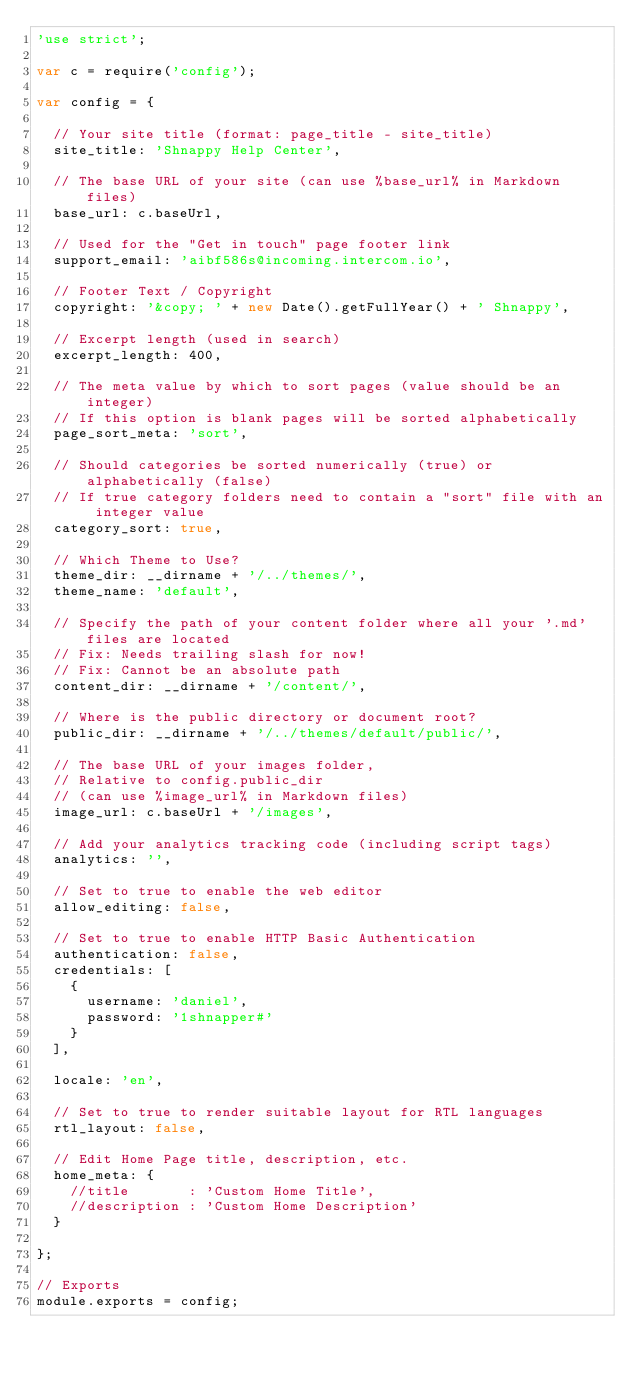Convert code to text. <code><loc_0><loc_0><loc_500><loc_500><_JavaScript_>'use strict';

var c = require('config');

var config = {

  // Your site title (format: page_title - site_title)
  site_title: 'Shnappy Help Center',

  // The base URL of your site (can use %base_url% in Markdown files)
  base_url: c.baseUrl,

  // Used for the "Get in touch" page footer link
  support_email: 'aibf586s@incoming.intercom.io',

  // Footer Text / Copyright
  copyright: '&copy; ' + new Date().getFullYear() + ' Shnappy',

  // Excerpt length (used in search)
  excerpt_length: 400,

  // The meta value by which to sort pages (value should be an integer)
  // If this option is blank pages will be sorted alphabetically
  page_sort_meta: 'sort',

  // Should categories be sorted numerically (true) or alphabetically (false)
  // If true category folders need to contain a "sort" file with an integer value
  category_sort: true,

  // Which Theme to Use?
  theme_dir: __dirname + '/../themes/',
  theme_name: 'default',

  // Specify the path of your content folder where all your '.md' files are located
  // Fix: Needs trailing slash for now!
  // Fix: Cannot be an absolute path
  content_dir: __dirname + '/content/',

  // Where is the public directory or document root?
  public_dir: __dirname + '/../themes/default/public/',

  // The base URL of your images folder,
  // Relative to config.public_dir
  // (can use %image_url% in Markdown files)
  image_url: c.baseUrl + '/images',

  // Add your analytics tracking code (including script tags)
  analytics: '',

  // Set to true to enable the web editor
  allow_editing: false,

  // Set to true to enable HTTP Basic Authentication
  authentication: false,
  credentials: [
    {
      username: 'daniel',
      password: '1shnapper#'
    }
  ],

  locale: 'en',

  // Set to true to render suitable layout for RTL languages
  rtl_layout: false,

  // Edit Home Page title, description, etc.
  home_meta: {
    //title       : 'Custom Home Title',
    //description : 'Custom Home Description'
  }

};

// Exports
module.exports = config;
</code> 